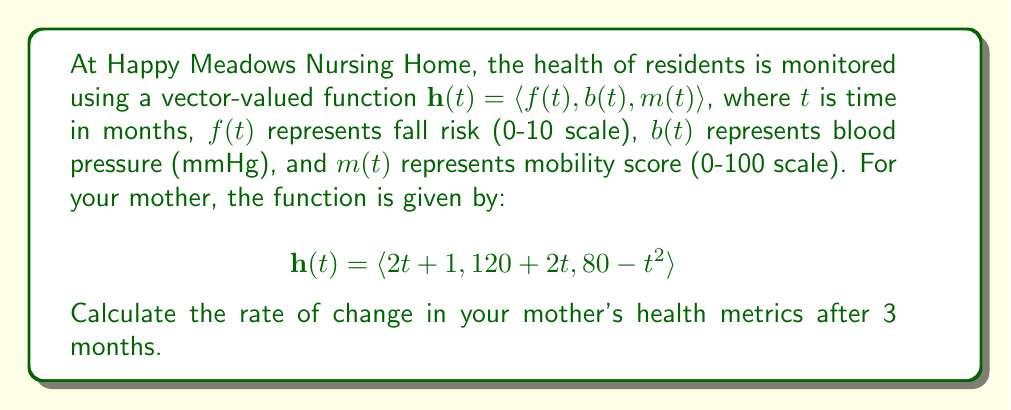Help me with this question. To find the rate of change in the health metrics, we need to calculate the derivative of the vector-valued function $\mathbf{h}(t)$ and then evaluate it at $t = 3$.

1) First, let's find $\mathbf{h}'(t)$:
   $$\mathbf{h}'(t) = \langle f'(t), b'(t), m'(t) \rangle$$

2) Calculate each component:
   $f'(t) = \frac{d}{dt}(2t + 1) = 2$
   $b'(t) = \frac{d}{dt}(120 + 2t) = 2$
   $m'(t) = \frac{d}{dt}(80 - t^2) = -2t$

3) Therefore, $\mathbf{h}'(t) = \langle 2, 2, -2t \rangle$

4) Evaluate $\mathbf{h}'(t)$ at $t = 3$:
   $$\mathbf{h}'(3) = \langle 2, 2, -2(3) \rangle = \langle 2, 2, -6 \rangle$$

5) Interpret the result:
   - Fall risk is increasing at a rate of 2 units per month
   - Blood pressure is increasing at a rate of 2 mmHg per month
   - Mobility score is decreasing at a rate of 6 units per month
Answer: $\langle 2, 2, -6 \rangle$ 